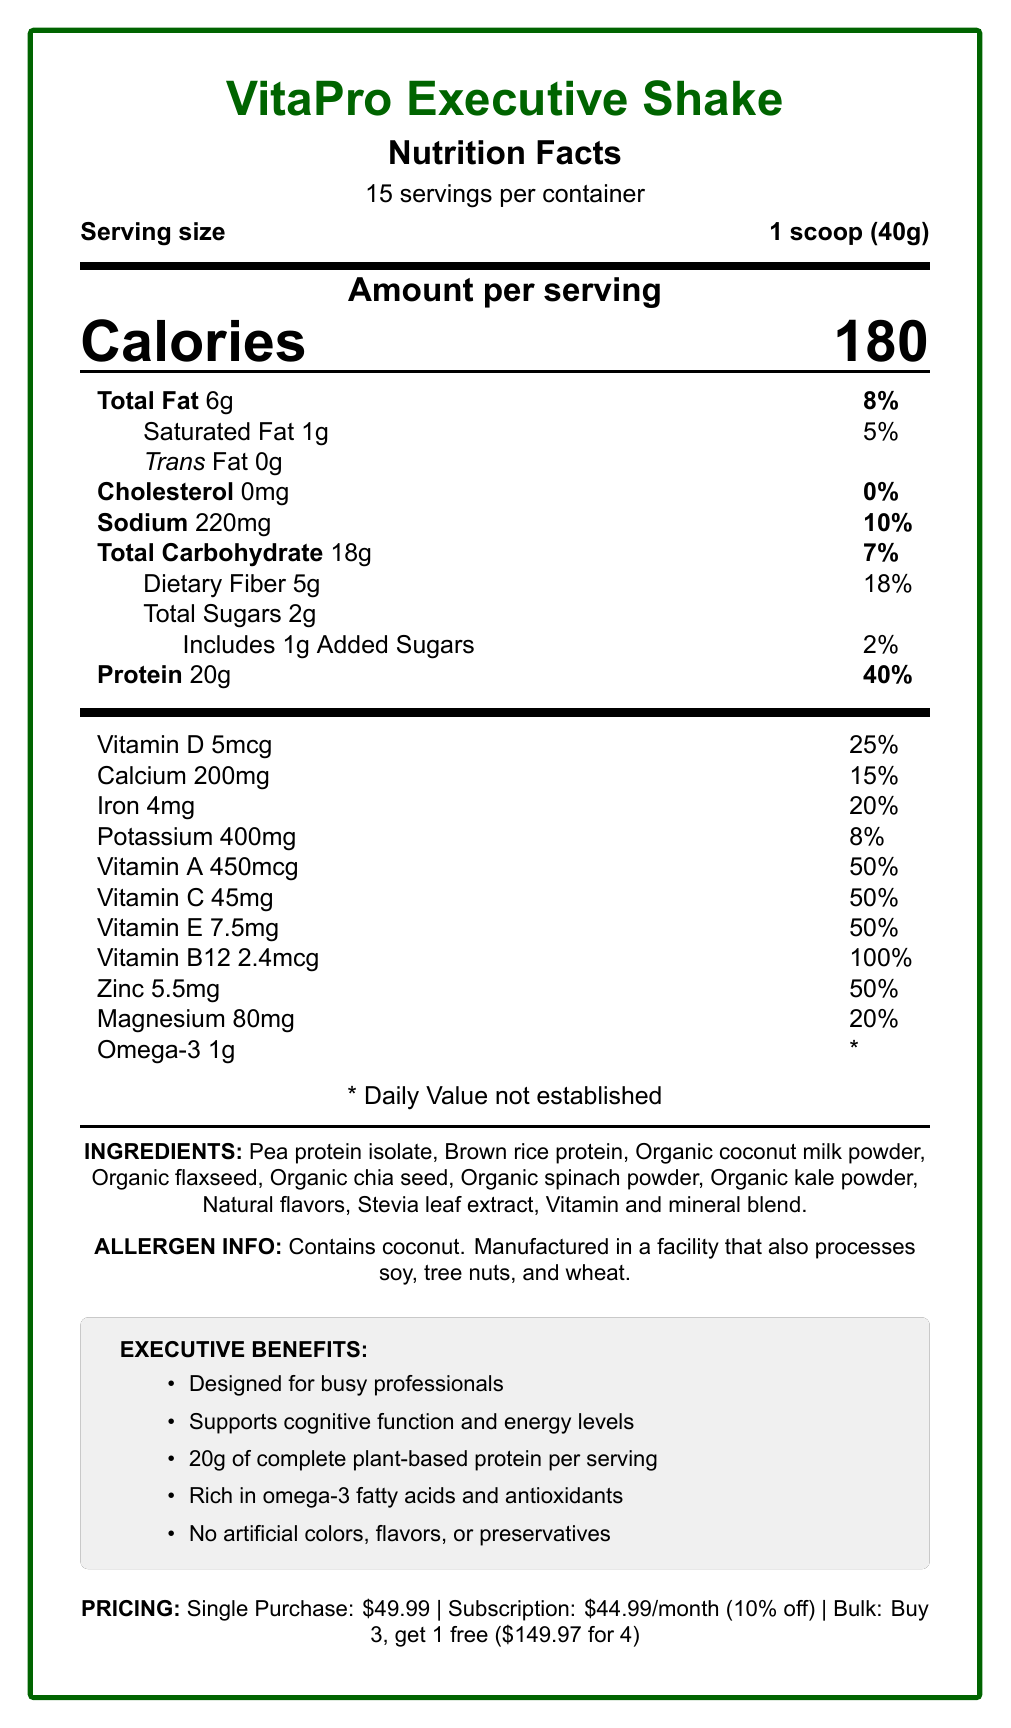What is the serving size of VitaPro Executive Shake? The serving size is mentioned clearly on the document as "1 scoop (40g)".
Answer: 1 scoop (40g) How many servings are there per container? The document states that there are 15 servings per container.
Answer: 15 How many calories are in one serving of VitaPro Executive Shake? The document specifies that each serving contains 180 calories.
Answer: 180 What percentage of the daily value for protein does one serving provide? The document lists protein content as 20g per serving, which is 40% of the daily value.
Answer: 40% How much dietary fiber is in a serving? The dietary fiber per serving is 5g as shown in the document.
Answer: 5g Which nutrient contributes the highest percentage of daily value per serving? 
A. Vitamin D 
B. Iron 
C. Vitamin B12 
D. Calcium Vitamin B12 contributes the highest percentage of daily value per serving at 100%.
Answer: C What is the total fat content per serving? A. 5g B. 6g C. 8g D. 10g The total fat content per serving is 6g, as indicated in the document.
Answer: B Is there any cholesterol in VitaPro Executive Shake? The document clearly states that there is 0mg of cholesterol in the shake.
Answer: No Does the shake contain any added sugars? The document shows that there is 1g of added sugars per serving.
Answer: Yes Summarize the overall information provided in the document. The updated summary captures the main elements such as nutritional content, ingredients, allergen information, product benefits, and pricing plans.
Answer: The document provides a comprehensive Nutrition Facts Label for VitaPro Executive Shake, a plant-based meal replacement shake designed for health-conscious professionals. It details serving size, number of servings per container, calories, nutrient amounts and their daily value percentages, ingredient list, allergen information, and marketing claims. The product's benefits are highlighted along with pricing strategy options. What are the ingredients in VitaPro Executive Shake? These are listed under the "INGREDIENTS" section in the document.
Answer: Pea protein isolate, Brown rice protein, Organic coconut milk powder, Organic flaxseed, Organic chia seed, Organic spinach powder, Organic kale powder, Natural flavors, Stevia leaf extract, Vitamin and mineral blend. What is the allergen information for VitaPro Executive Shake? The allergen information section provides this detail.
Answer: Contains coconut. Manufactured in a facility that also processes soy, tree nuts, and wheat. What are the marketing claims of VitaPro Executive Shake? The marketing claims are listed in the "EXECUTIVE BENEFITS" section of the document.
Answer: Designed for busy professionals, Supports cognitive function and energy levels, 20g of complete plant-based protein per serving, Rich in omega-3 fatty acids and antioxidants, No artificial colors, flavors, or preservatives What is the price for a single container when purchased without a subscription? Under the "PRICING" section, it lists $49.99 for a single purchase.
Answer: $49.99 How much potassium does one serving contain? The document indicates that one serving contains 400mg of potassium.
Answer: 400mg How many grams of total carbohydrates are there in a serving of VitaPro Executive Shake? The document states that each serving contains 18g of total carbohydrates.
Answer: 18g Is the daily value for omega-3 established on the label? The label shows an asterisk (*) next to omega-3, indicating that the daily value is not established.
Answer: No Can we determine the number of calories from fat in one serving of VitaPro Executive Shake from the document? The document does not provide the calories from fat directly; it only provides total fat content and calories per serving.
Answer: Not enough information What is the bulk discount price for VitaPro Executive Shake if purchasing 4 containers? The "PRICING" section mentions a bulk discount price of $149.97 for 4 containers.
Answer: $149.97 